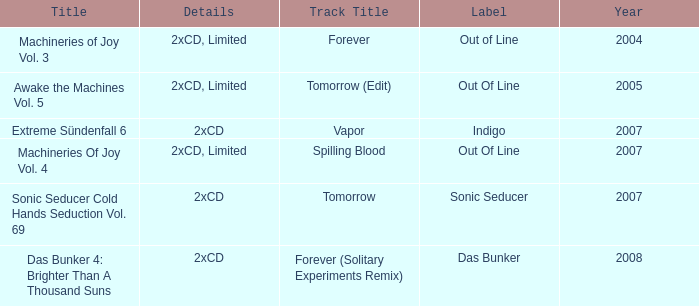What average year contains the title of machineries of joy vol. 4? 2007.0. 